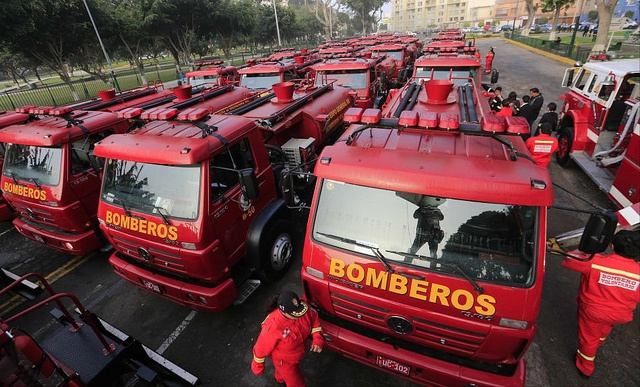Describe the objects in this image and their specific colors. I can see truck in black, brown, maroon, and salmon tones, truck in black, maroon, darkgray, and brown tones, truck in black, maroon, brown, and gray tones, truck in black, maroon, gray, and darkgray tones, and people in black, brown, and maroon tones in this image. 